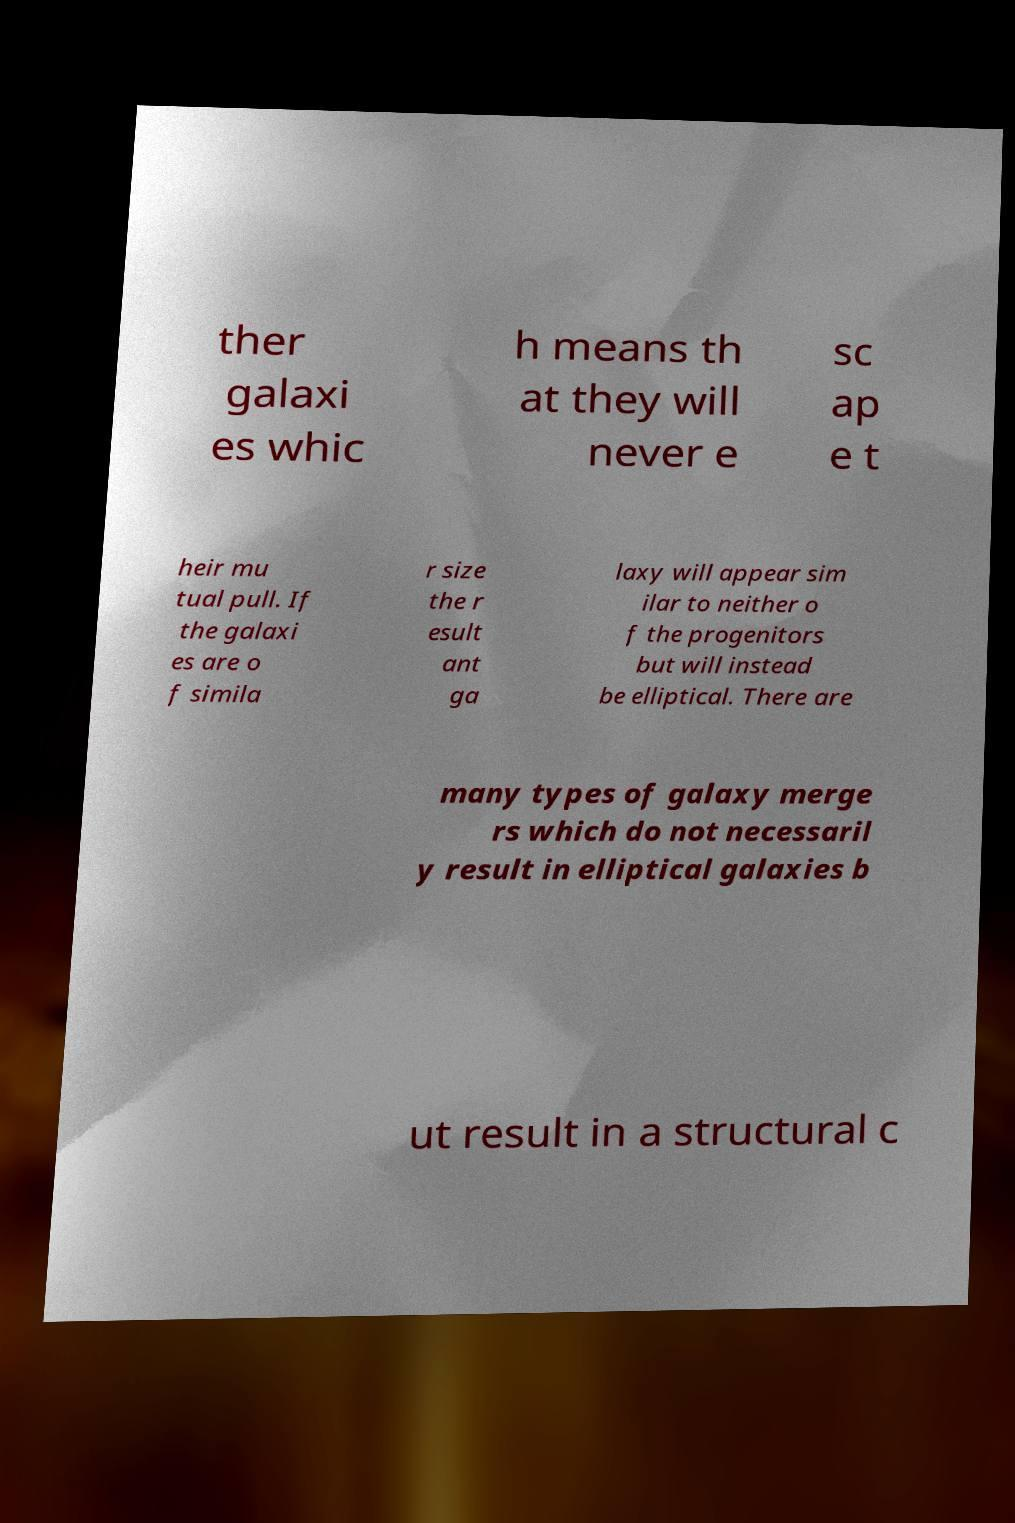Please read and relay the text visible in this image. What does it say? ther galaxi es whic h means th at they will never e sc ap e t heir mu tual pull. If the galaxi es are o f simila r size the r esult ant ga laxy will appear sim ilar to neither o f the progenitors but will instead be elliptical. There are many types of galaxy merge rs which do not necessaril y result in elliptical galaxies b ut result in a structural c 